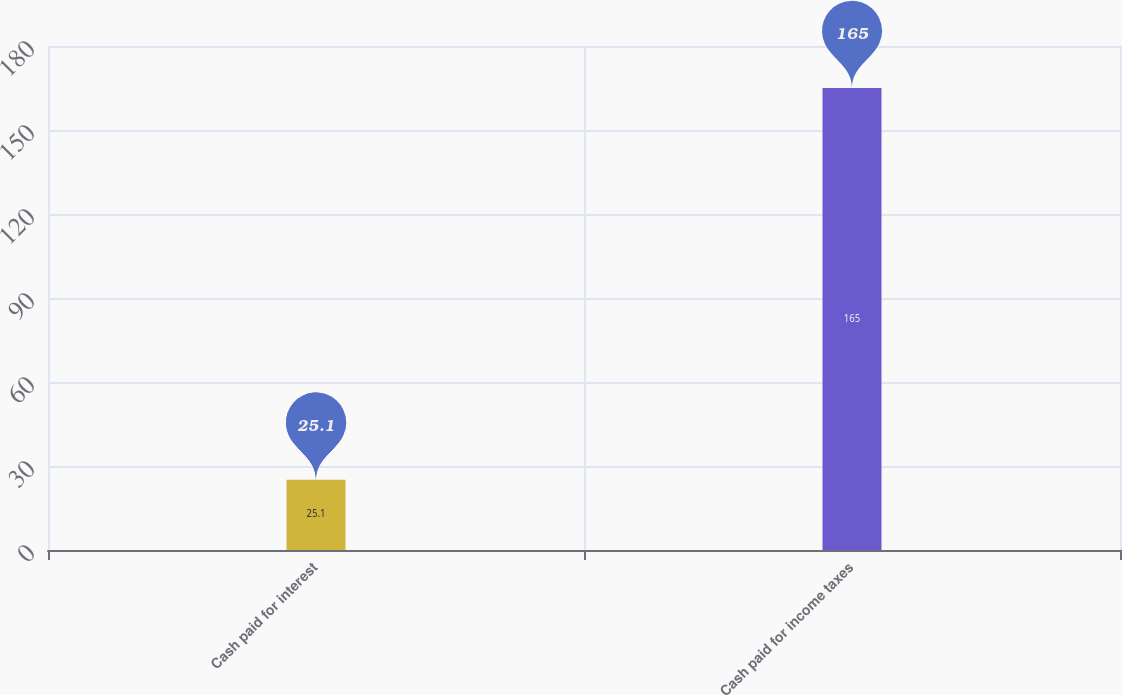Convert chart to OTSL. <chart><loc_0><loc_0><loc_500><loc_500><bar_chart><fcel>Cash paid for interest<fcel>Cash paid for income taxes<nl><fcel>25.1<fcel>165<nl></chart> 